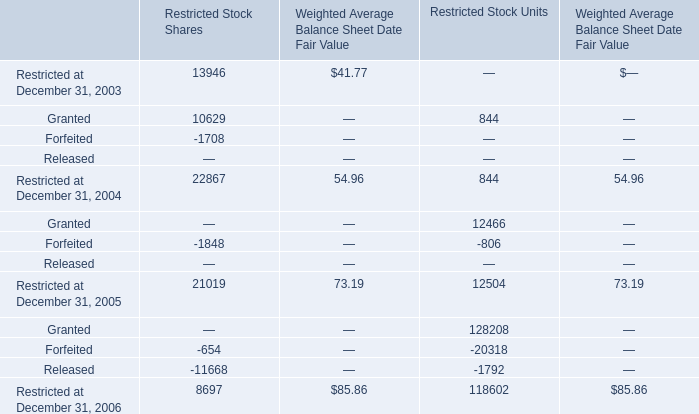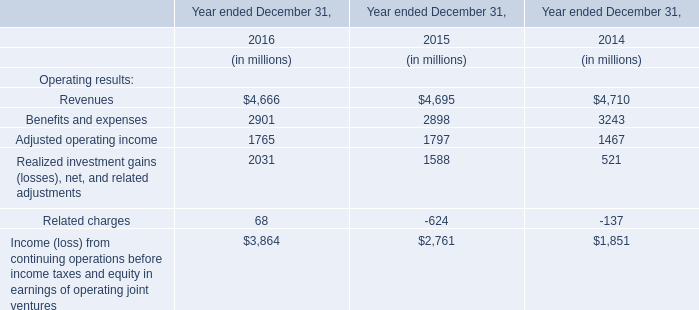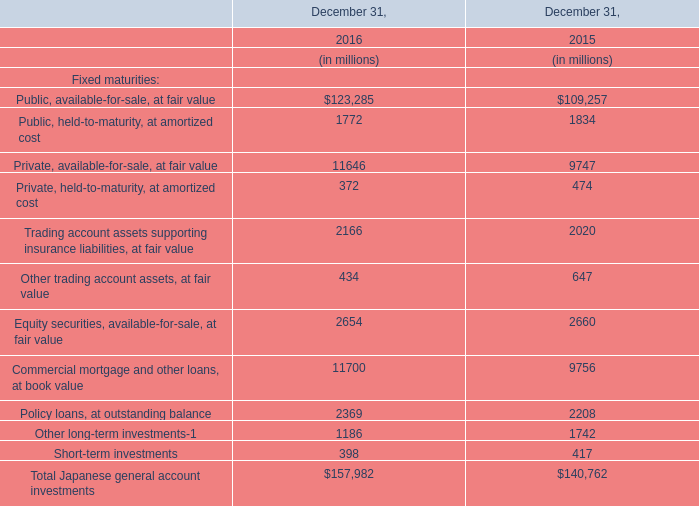In the year with the most Granted for Restricted Stock Units, what is the growth rate of Restricted at December 31, 2005 for Restricted Stock Units? 
Computations: ((12504 - 844) / 844)
Answer: 13.81517. 